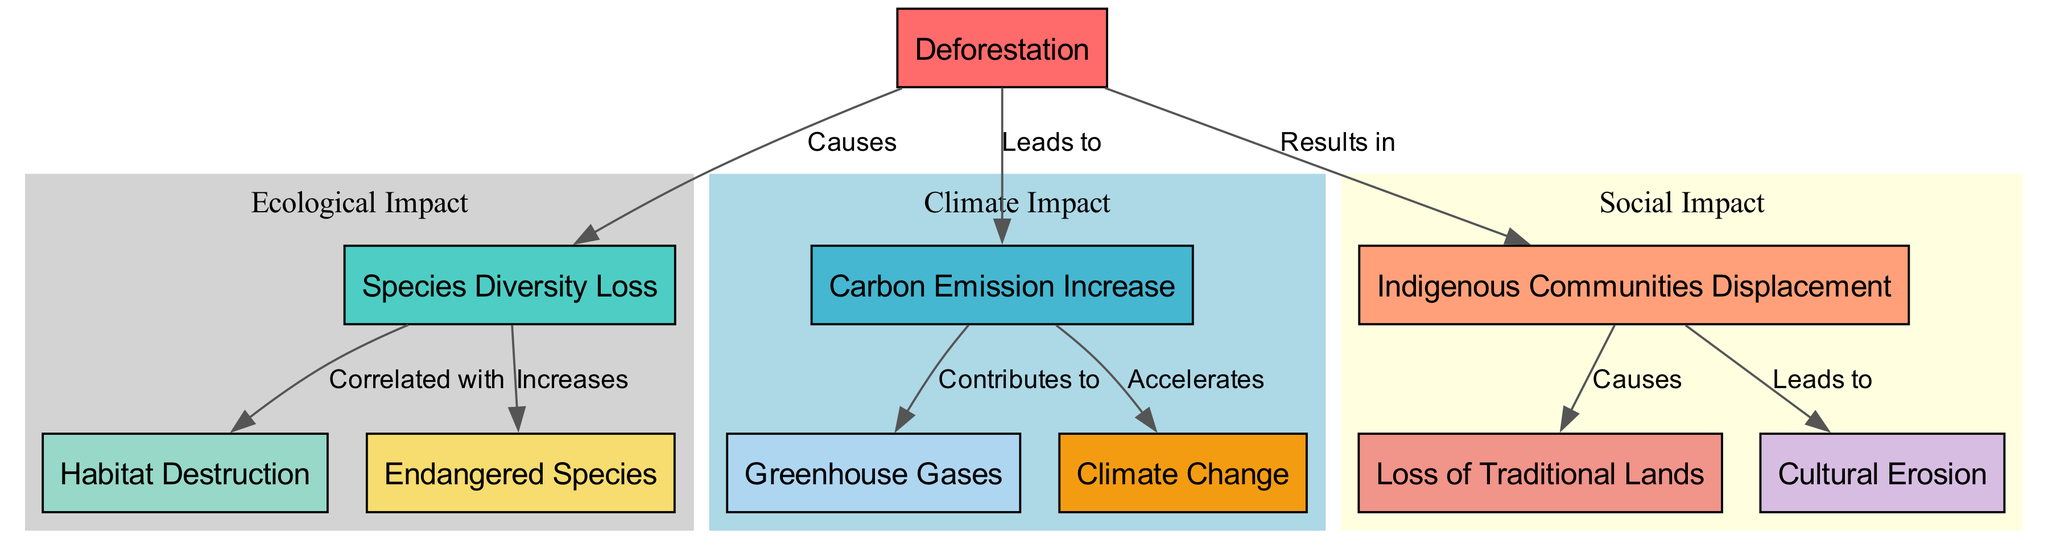What does deforestation lead to? According to the diagram, the edge connecting "deforestation" to "carbon increase" is labeled "Leads to". This indicates that one direct result of deforestation is an increase in carbon emissions.
Answer: carbon emission increase How many edges are in the diagram? By counting the connections (edges) drawn between nodes in the diagram, there are a total of 8 connections represented.
Answer: 8 What does species diversity loss increase? The diagram shows that "species loss" is connected to "endangered species" with an edge labeled "Increases". Therefore, species diversity loss is directly linked to an increase in endangered species.
Answer: Endangered Species What does indigenous displacement cause? The edge labeled "Causes" connects "indigenous displacement" to "traditional lands loss". This indicates that the displacement of indigenous communities results in the loss of their traditional lands.
Answer: Loss of Traditional Lands What is the correlation between species loss and habitat destruction? The edge labeled "Correlated with" directly links "species loss" to "habitat destruction". This presence of a correlation indicates that as species diversity diminishes, habitat destruction increases.
Answer: Habitat Destruction How does carbon increase affect climate change? According to the diagram, there is an edge labeled "Accelerates" that connects "carbon increase" to "climate change". This indicates that an increase in carbon emissions has a direct effect on accelerating climate change.
Answer: Climate Change What is the primary component that contributes to greenhouse gases? The edge labeled "Contributes to" connecting "carbon increase" and "greenhouse gases" indicates that the increase in carbon emissions directly contributes to the presence of greenhouse gases in the atmosphere.
Answer: Greenhouse Gases What leads to cultural erosion? The diagram shows an arrow from "indigenous displacement" to "cultural erosion", with the label "Leads to". This indicates that the displacement of indigenous communities directly leads to the erosion of their cultures.
Answer: Cultural Erosion 